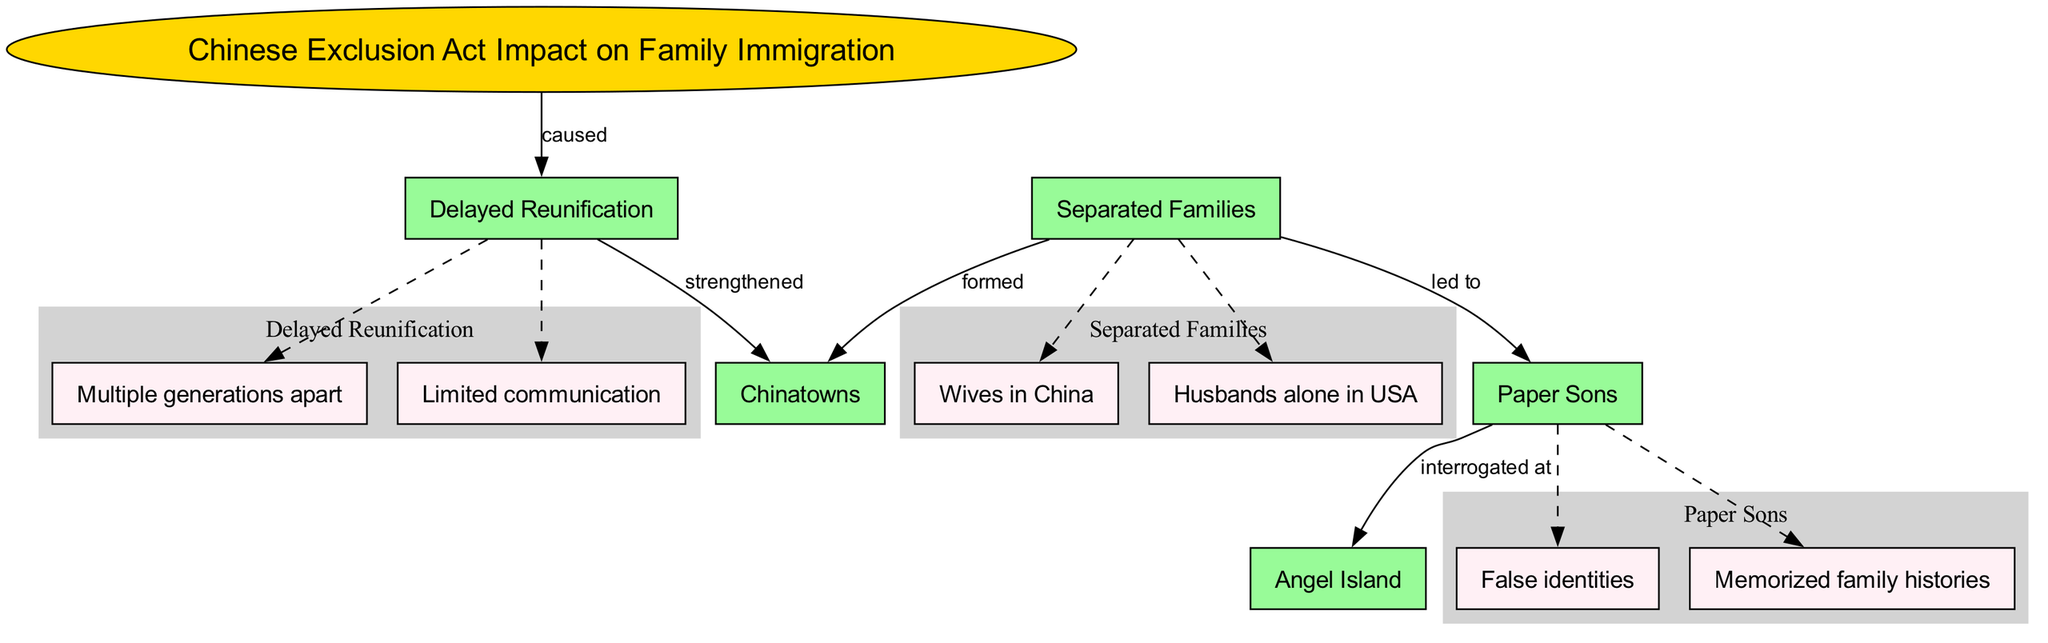What is the central concept of the diagram? The central concept is clearly labeled at the center of the diagram, which is "Chinese Exclusion Act Impact on Family Immigration." This is indicated by its distinct shape (ellipse) and formatting (gold fill, bold text).
Answer: Chinese Exclusion Act Impact on Family Immigration How many main nodes are present in the diagram? The main nodes are listed and connected to the central concept. By counting the names listed under "main_nodes," which are five in total, we find that there are five main nodes.
Answer: 5 What relationship connects "Separated Families" to "Paper Sons"? The connection is indicated by a directed edge labeled "led to" between the two nodes "Separated Families" and "Paper Sons." This arrow signifies the direction of the relationship, indicating one leads to the other.
Answer: led to Which node is associated with multiple generations apart? "Multiple generations apart" is a sub-node under the primary node "Delayed Reunification," as indicated by the structure of the diagram where it branches off from this node.
Answer: Delayed Reunification What caused "Delayed Reunification" according to the diagram? The diagram specifically states that "Chinese Exclusion Act Impact on Family Immigration" caused "Delayed Reunification." This is evidenced by the directed edge labeled "caused" connecting these two nodes.
Answer: Chinese Exclusion Act Impact on Family Immigration Which main node is connected to "Chinatowns"? Two main nodes connect to "Chinatowns." The first is from "Separated Families," indicated by the "formed" label, and the second is from "Delayed Reunification," indicated by "strengthened." Both connections show how Chinatowns are impacted by these main nodes.
Answer: Separated Families and Delayed Reunification What were "Paper Sons" interrogated at? The label on the edge from "Paper Sons" directly points to "Angel Island," indicating that this is the location where they were interrogated. The relationship is further distinguished by the label "interrogated at."
Answer: Angel Island How does "Delayed Reunification" affect "Chinatowns"? The edge from "Delayed Reunification" to "Chinatowns" is labeled "strengthened," showing a direct connection that illustrates the impact of delayed family reunifications on the formation or resilience of Chinatowns.
Answer: strengthened 